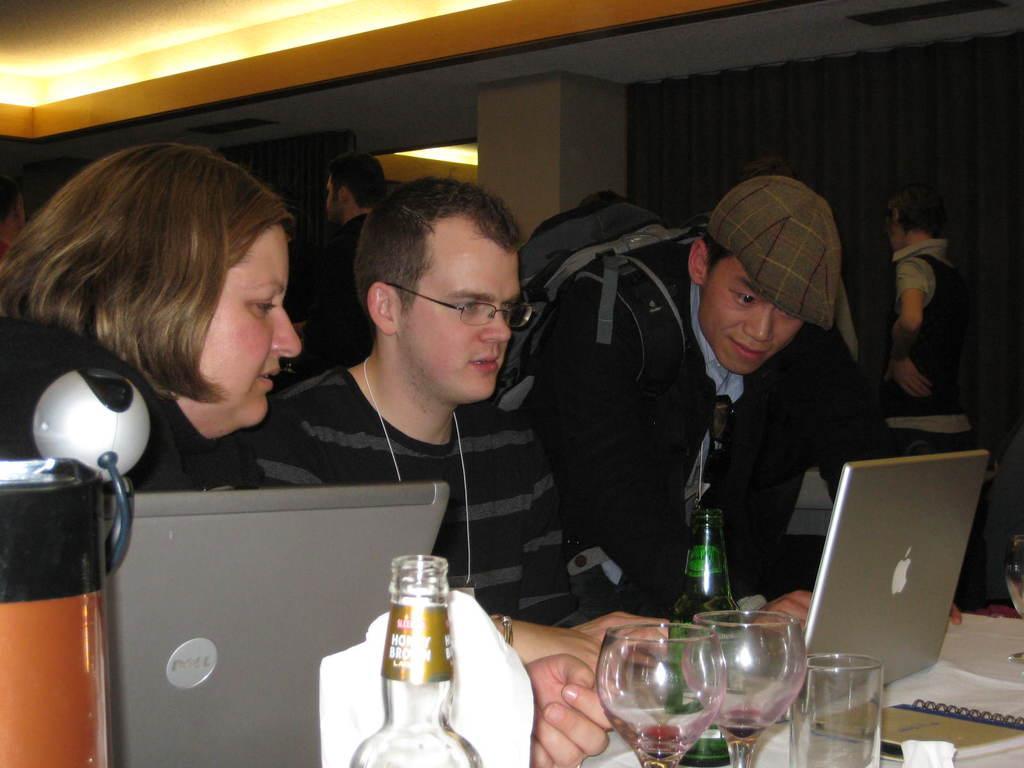Describe this image in one or two sentences. This is a picture of three people sitting on chair in front of a table on which there are some glasses, laptops, bottles and tissues and notes and among them a person is having the spectacles and the other guy is wearing a backpack and a lady has short hair. 